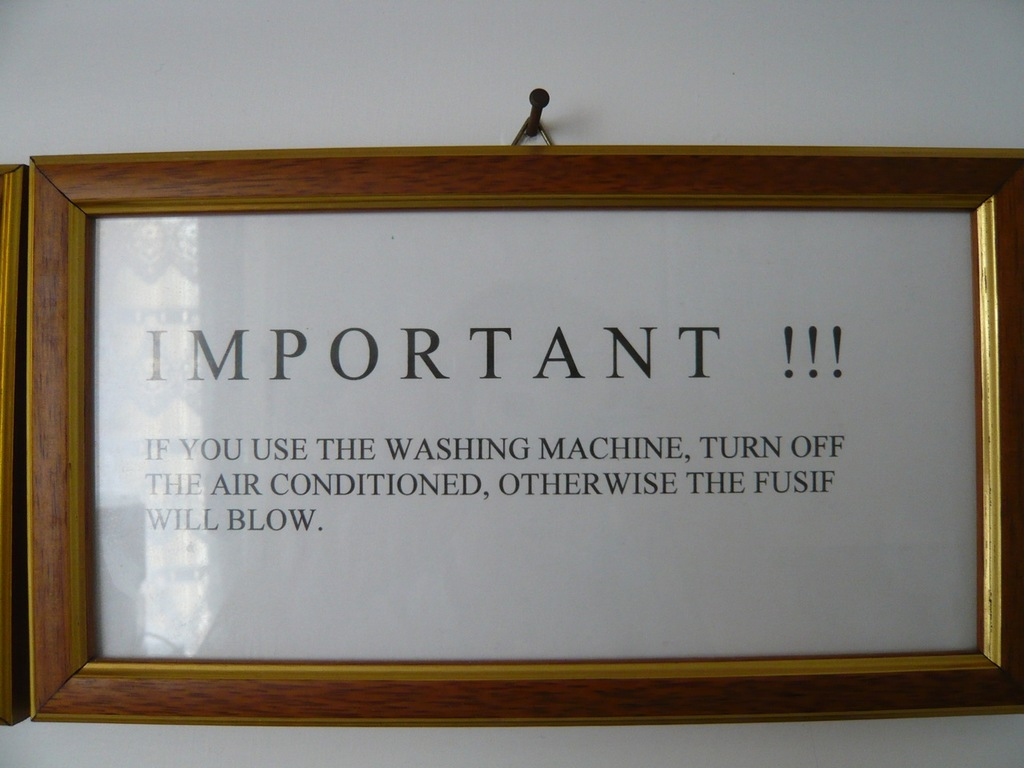What do you see happening in this image? The image captures a framed notice hanging on a white wall. The notice, written in all caps, serves as a warning about the use of a washing machine and air conditioning simultaneously. It states, "IMPORTANT !!! IF YOU USE THE WASHING MACHINE, TURN OFF THE AIR CONDITIONED, OTHERWISE THE FUSIF WILL BLOW." The message suggests that using both appliances at the same time could potentially blow a fuse, indicating a concern for electrical safety. 